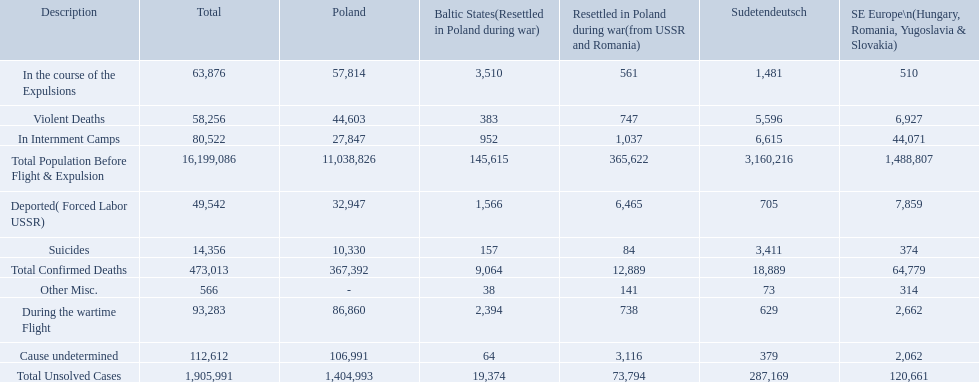What are all of the descriptions? Total Population Before Flight & Expulsion, Violent Deaths, Suicides, Deported( Forced Labor USSR), In Internment Camps, During the wartime Flight, In the course of the Expulsions, Cause undetermined, Other Misc., Total Confirmed Deaths, Total Unsolved Cases. What were their total number of deaths? 16,199,086, 58,256, 14,356, 49,542, 80,522, 93,283, 63,876, 112,612, 566, 473,013, 1,905,991. What about just from violent deaths? 58,256. What were all of the types of deaths? Violent Deaths, Suicides, Deported( Forced Labor USSR), In Internment Camps, During the wartime Flight, In the course of the Expulsions, Cause undetermined, Other Misc. And their totals in the baltic states? 383, 157, 1,566, 952, 2,394, 3,510, 64, 38. Were more deaths in the baltic states caused by undetermined causes or misc.? Cause undetermined. 